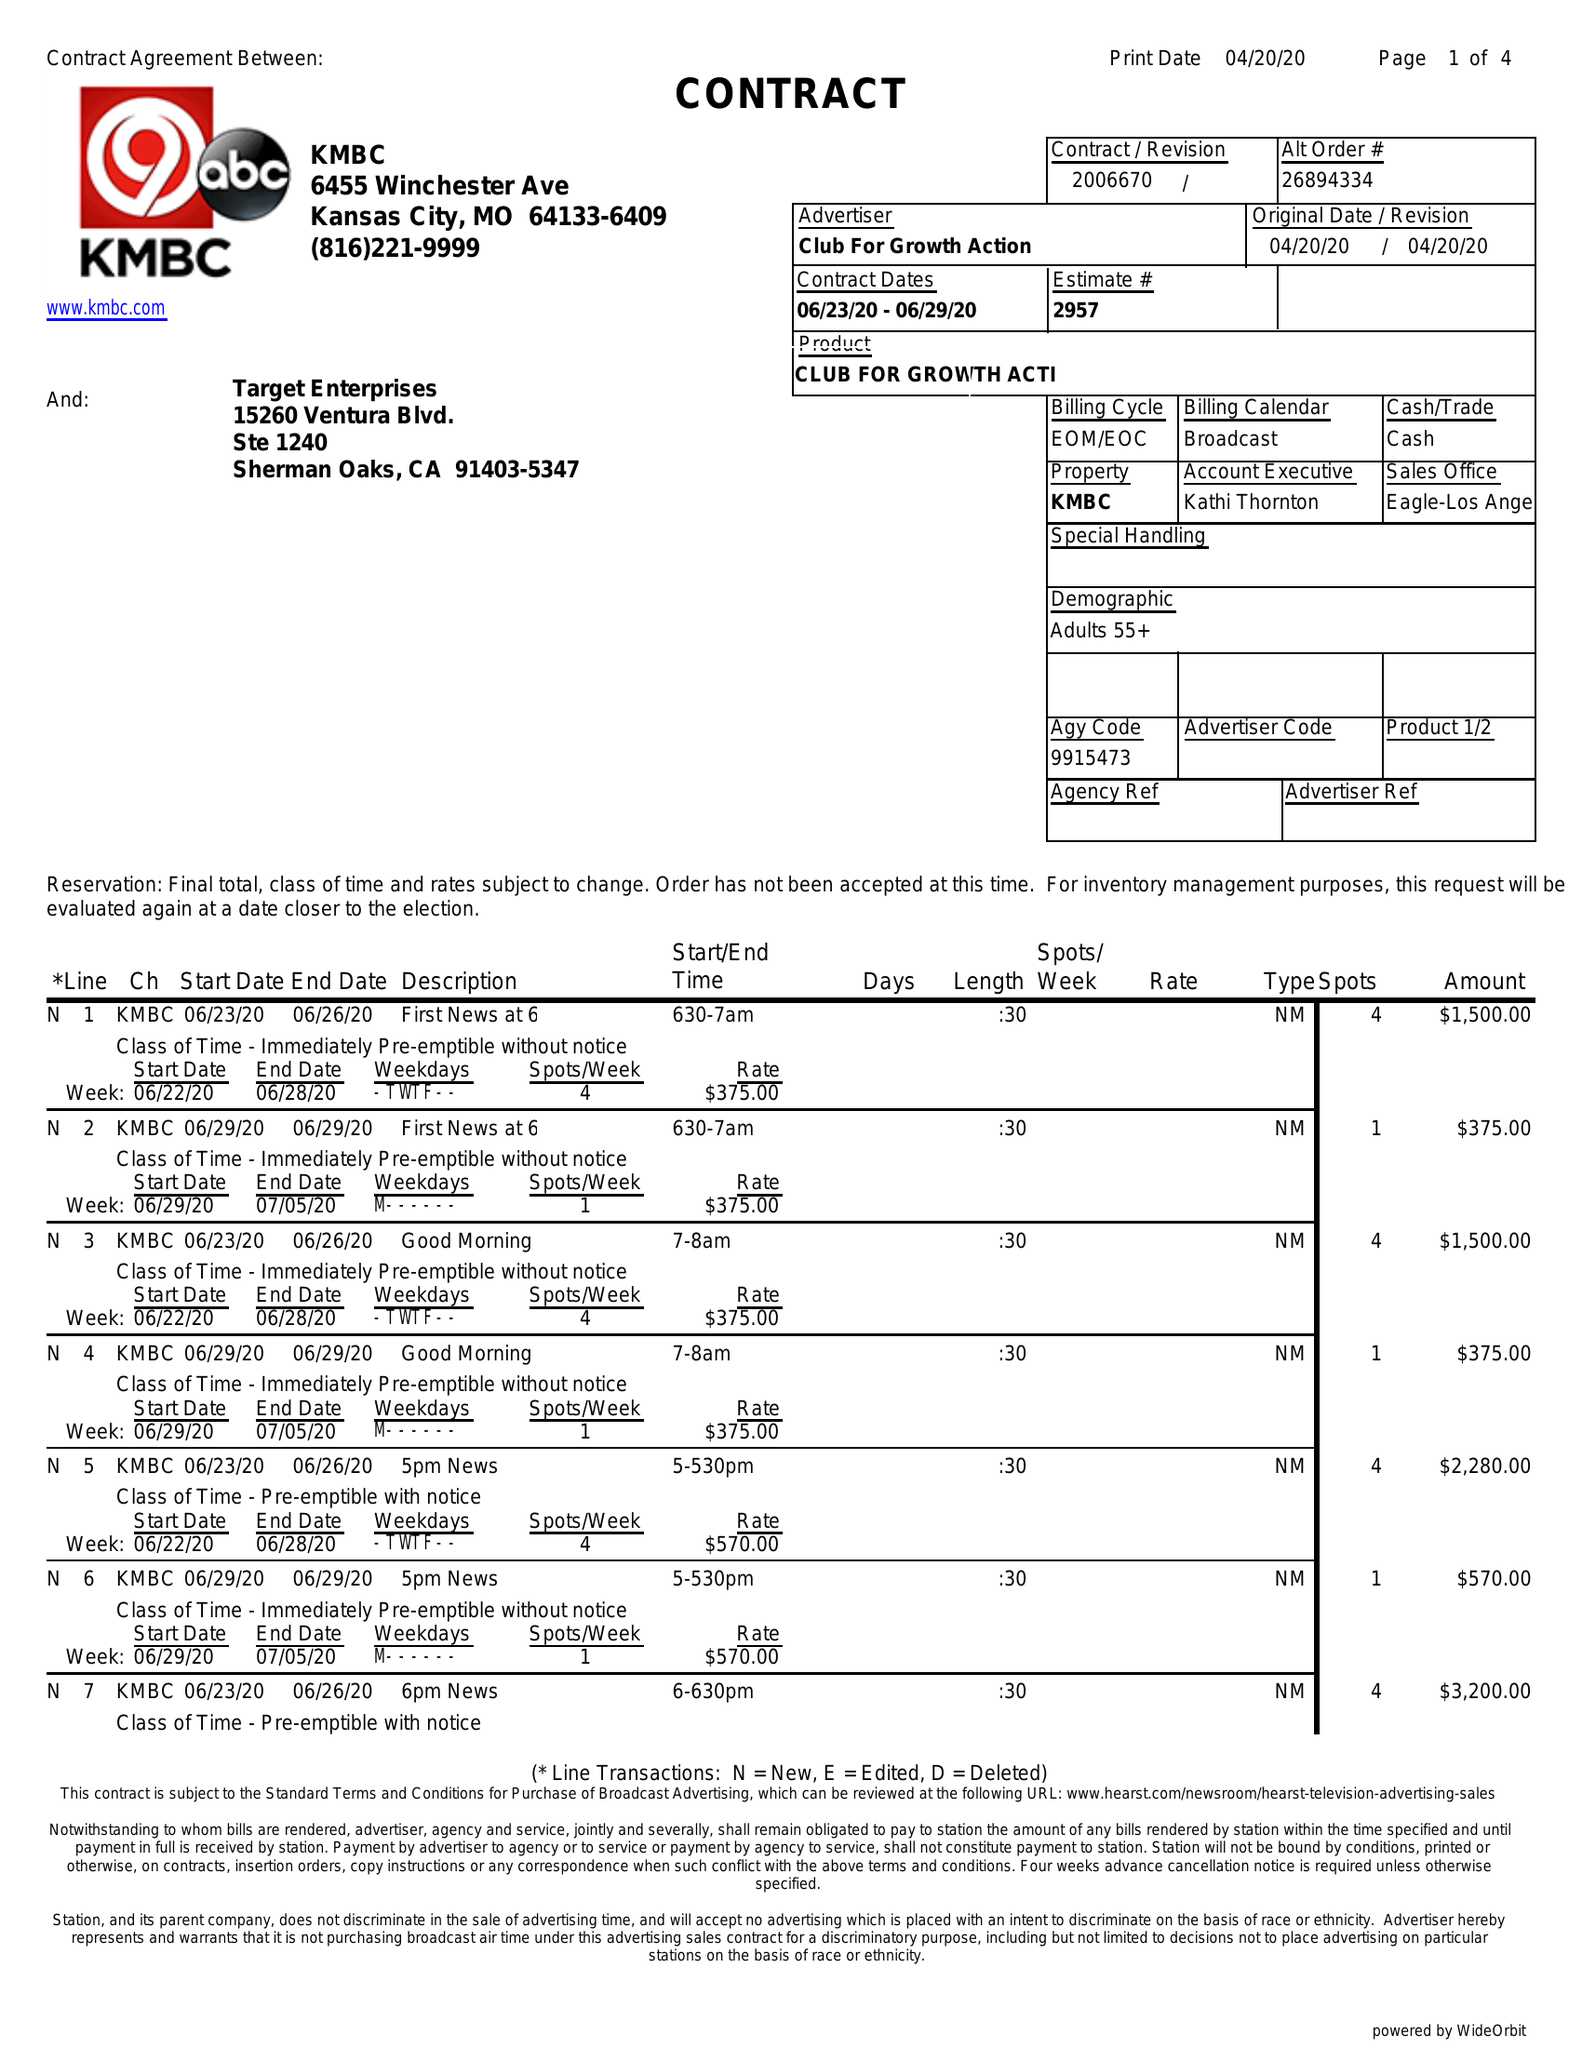What is the value for the advertiser?
Answer the question using a single word or phrase. CLUB FOR GROWTH ACTION 